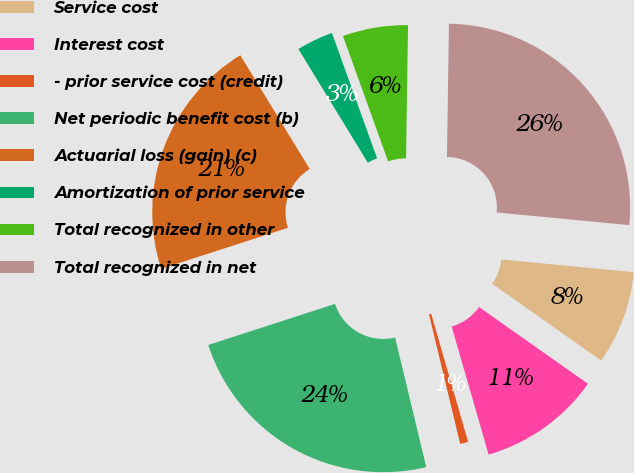<chart> <loc_0><loc_0><loc_500><loc_500><pie_chart><fcel>Service cost<fcel>Interest cost<fcel>- prior service cost (credit)<fcel>Net periodic benefit cost (b)<fcel>Actuarial loss (gain) (c)<fcel>Amortization of prior service<fcel>Total recognized in other<fcel>Total recognized in net<nl><fcel>8.25%<fcel>10.76%<fcel>0.71%<fcel>23.77%<fcel>21.26%<fcel>3.22%<fcel>5.74%<fcel>26.28%<nl></chart> 